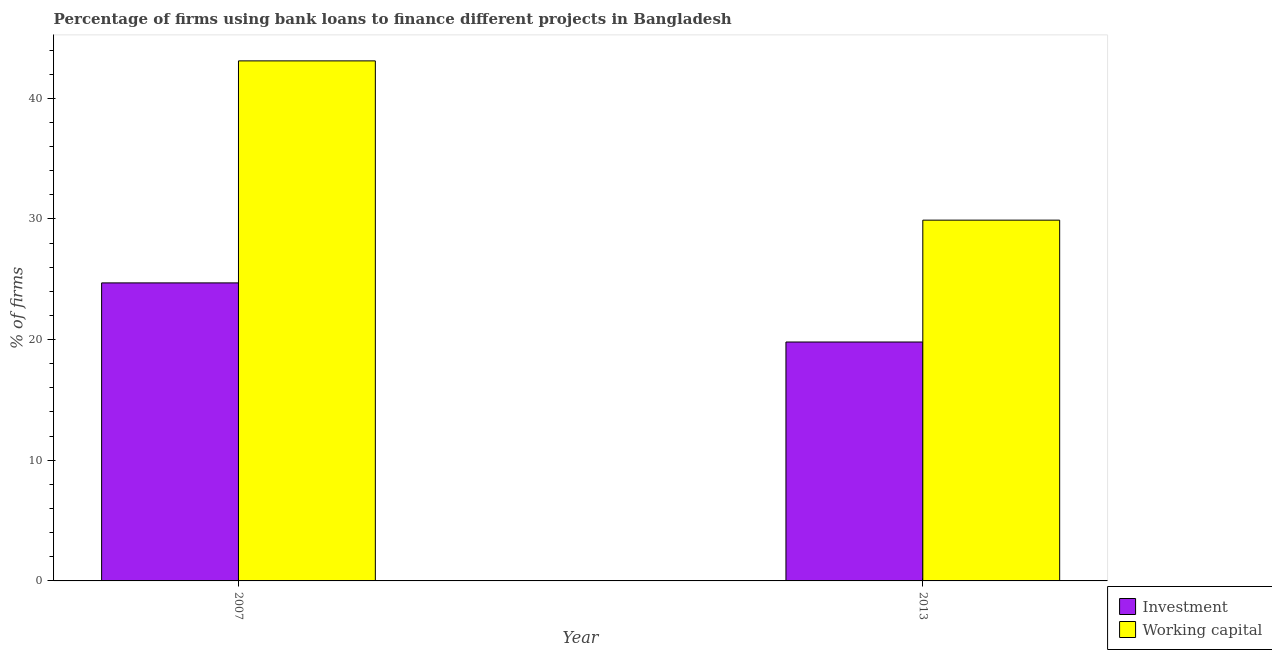How many groups of bars are there?
Make the answer very short. 2. Are the number of bars per tick equal to the number of legend labels?
Your response must be concise. Yes. What is the percentage of firms using banks to finance investment in 2013?
Your answer should be compact. 19.8. Across all years, what is the maximum percentage of firms using banks to finance investment?
Give a very brief answer. 24.7. Across all years, what is the minimum percentage of firms using banks to finance investment?
Provide a succinct answer. 19.8. In which year was the percentage of firms using banks to finance working capital maximum?
Provide a short and direct response. 2007. What is the total percentage of firms using banks to finance investment in the graph?
Offer a terse response. 44.5. What is the difference between the percentage of firms using banks to finance investment in 2007 and that in 2013?
Ensure brevity in your answer.  4.9. What is the difference between the percentage of firms using banks to finance working capital in 2013 and the percentage of firms using banks to finance investment in 2007?
Provide a short and direct response. -13.2. What is the average percentage of firms using banks to finance investment per year?
Provide a succinct answer. 22.25. In the year 2013, what is the difference between the percentage of firms using banks to finance investment and percentage of firms using banks to finance working capital?
Your answer should be very brief. 0. In how many years, is the percentage of firms using banks to finance working capital greater than 42 %?
Your answer should be compact. 1. What is the ratio of the percentage of firms using banks to finance investment in 2007 to that in 2013?
Keep it short and to the point. 1.25. Is the percentage of firms using banks to finance working capital in 2007 less than that in 2013?
Provide a succinct answer. No. In how many years, is the percentage of firms using banks to finance working capital greater than the average percentage of firms using banks to finance working capital taken over all years?
Keep it short and to the point. 1. What does the 1st bar from the left in 2013 represents?
Provide a short and direct response. Investment. What does the 1st bar from the right in 2007 represents?
Offer a very short reply. Working capital. How many years are there in the graph?
Provide a succinct answer. 2. What is the difference between two consecutive major ticks on the Y-axis?
Your response must be concise. 10. Are the values on the major ticks of Y-axis written in scientific E-notation?
Provide a short and direct response. No. Does the graph contain any zero values?
Your response must be concise. No. Where does the legend appear in the graph?
Make the answer very short. Bottom right. What is the title of the graph?
Offer a very short reply. Percentage of firms using bank loans to finance different projects in Bangladesh. What is the label or title of the Y-axis?
Your answer should be compact. % of firms. What is the % of firms in Investment in 2007?
Your answer should be very brief. 24.7. What is the % of firms of Working capital in 2007?
Keep it short and to the point. 43.1. What is the % of firms of Investment in 2013?
Offer a terse response. 19.8. What is the % of firms of Working capital in 2013?
Your response must be concise. 29.9. Across all years, what is the maximum % of firms of Investment?
Keep it short and to the point. 24.7. Across all years, what is the maximum % of firms of Working capital?
Your answer should be very brief. 43.1. Across all years, what is the minimum % of firms of Investment?
Make the answer very short. 19.8. Across all years, what is the minimum % of firms in Working capital?
Make the answer very short. 29.9. What is the total % of firms in Investment in the graph?
Your answer should be very brief. 44.5. What is the difference between the % of firms in Investment in 2007 and the % of firms in Working capital in 2013?
Offer a terse response. -5.2. What is the average % of firms of Investment per year?
Give a very brief answer. 22.25. What is the average % of firms of Working capital per year?
Offer a terse response. 36.5. In the year 2007, what is the difference between the % of firms of Investment and % of firms of Working capital?
Offer a very short reply. -18.4. What is the ratio of the % of firms of Investment in 2007 to that in 2013?
Your response must be concise. 1.25. What is the ratio of the % of firms in Working capital in 2007 to that in 2013?
Provide a short and direct response. 1.44. What is the difference between the highest and the second highest % of firms of Investment?
Give a very brief answer. 4.9. What is the difference between the highest and the lowest % of firms of Investment?
Provide a short and direct response. 4.9. 